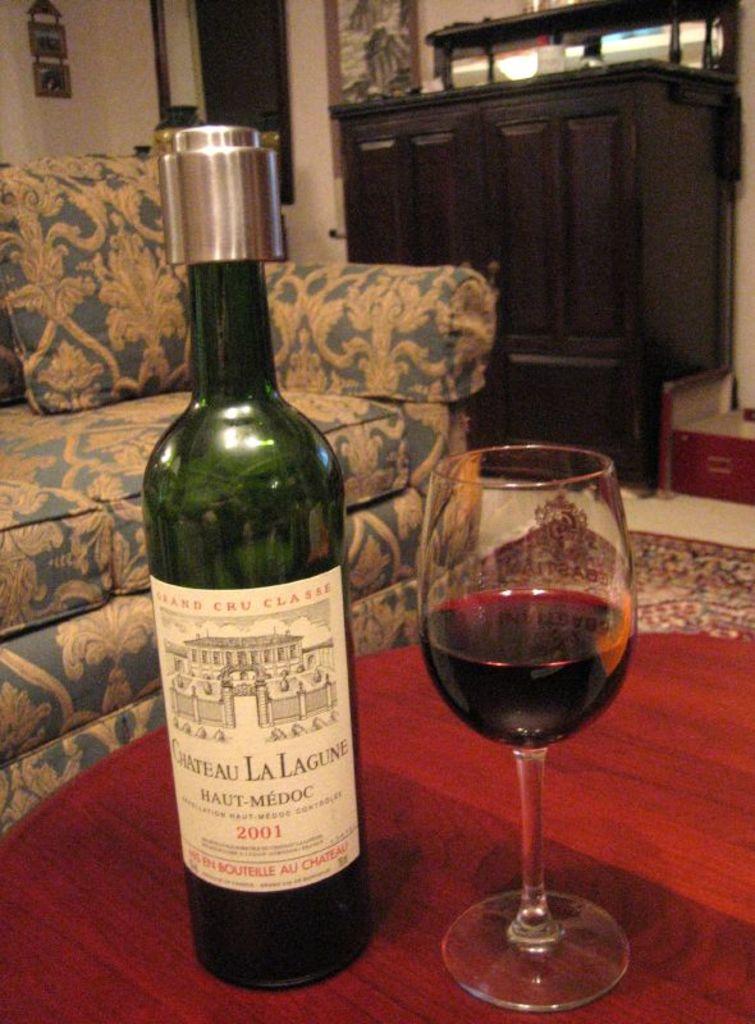What is the year written on the wine bottle?
Ensure brevity in your answer.  2001. What is the name of the bottle of wine?
Offer a terse response. Chateau la lagune. 